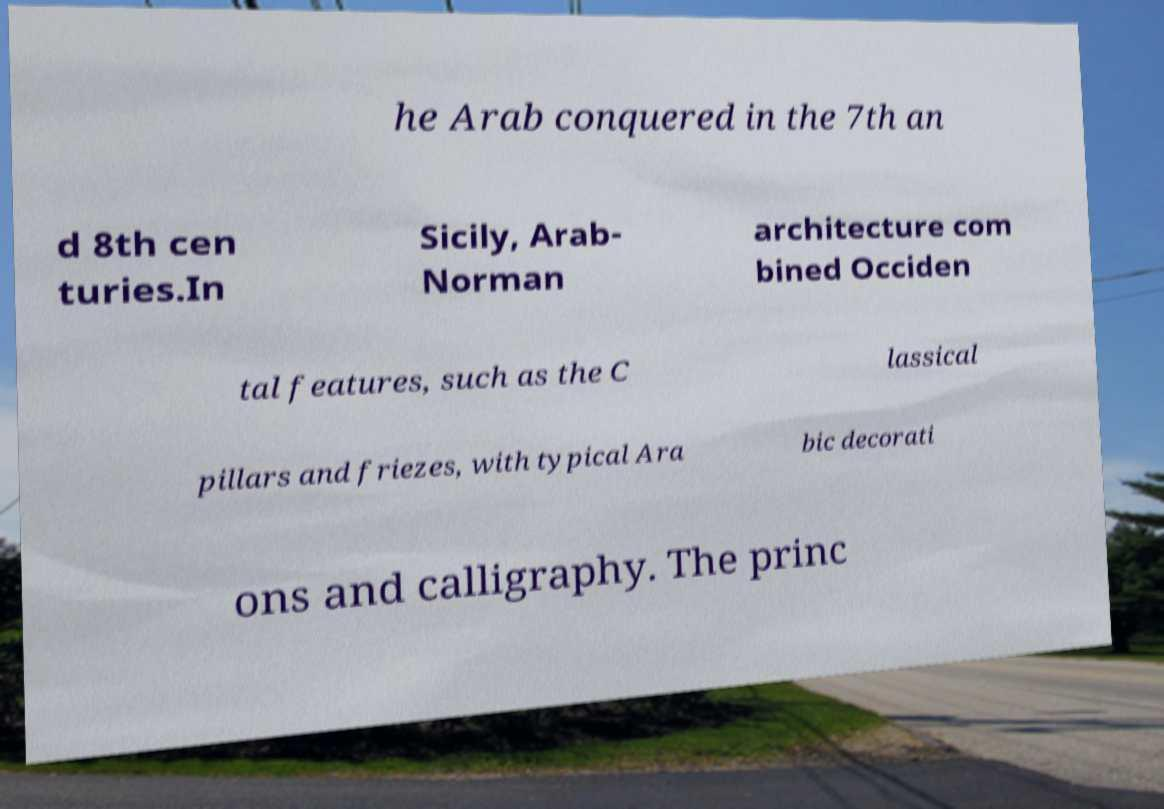Can you accurately transcribe the text from the provided image for me? he Arab conquered in the 7th an d 8th cen turies.In Sicily, Arab- Norman architecture com bined Occiden tal features, such as the C lassical pillars and friezes, with typical Ara bic decorati ons and calligraphy. The princ 